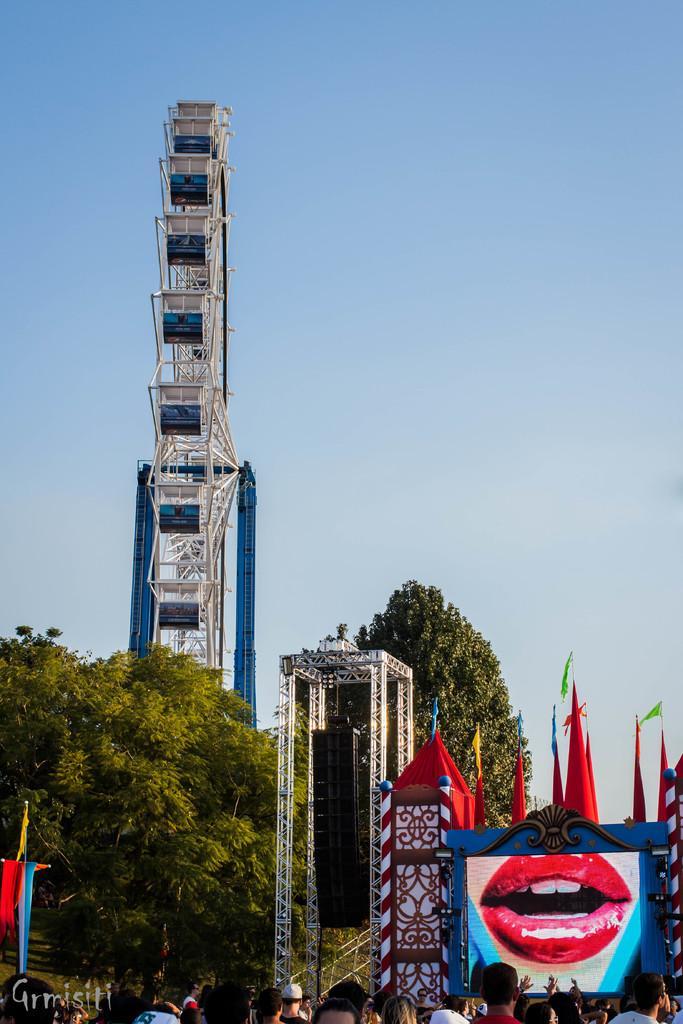Can you describe this image briefly? In this image there is a giant wheel, poles, screen lips of a person, flags, people and objects. In the background of the image there is the sky. At the bottom left side of the image there is a watermark. 